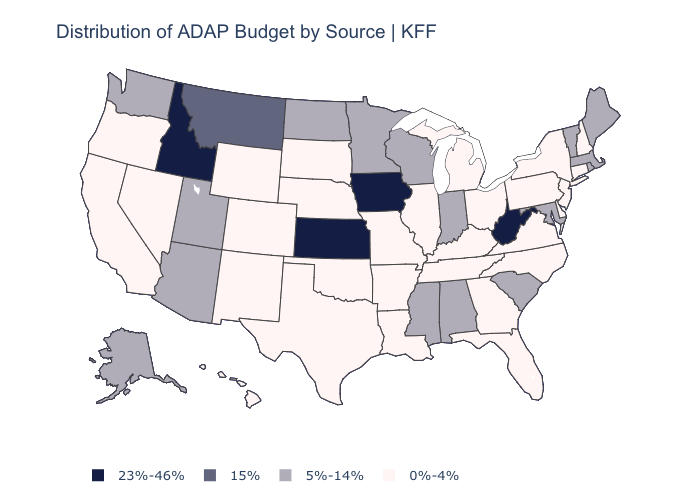Does Minnesota have a higher value than Kansas?
Short answer required. No. Does the first symbol in the legend represent the smallest category?
Write a very short answer. No. What is the highest value in the MidWest ?
Keep it brief. 23%-46%. Does the map have missing data?
Short answer required. No. Name the states that have a value in the range 0%-4%?
Concise answer only. Arkansas, California, Colorado, Connecticut, Delaware, Florida, Georgia, Hawaii, Illinois, Kentucky, Louisiana, Michigan, Missouri, Nebraska, Nevada, New Hampshire, New Jersey, New Mexico, New York, North Carolina, Ohio, Oklahoma, Oregon, Pennsylvania, South Dakota, Tennessee, Texas, Virginia, Wyoming. Is the legend a continuous bar?
Concise answer only. No. Among the states that border Vermont , which have the lowest value?
Keep it brief. New Hampshire, New York. Among the states that border Maine , which have the lowest value?
Quick response, please. New Hampshire. What is the highest value in states that border Mississippi?
Answer briefly. 5%-14%. What is the value of Virginia?
Keep it brief. 0%-4%. What is the value of Maine?
Short answer required. 5%-14%. How many symbols are there in the legend?
Short answer required. 4. What is the value of California?
Concise answer only. 0%-4%. What is the highest value in the USA?
Keep it brief. 23%-46%. 